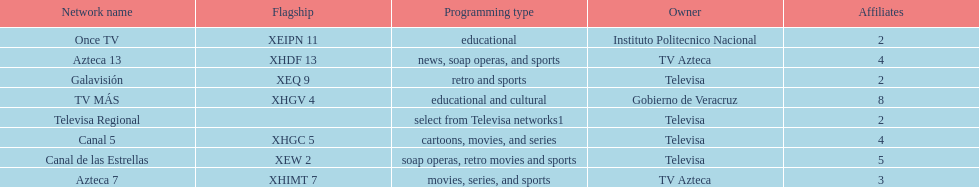Who has the most number of affiliates? TV MÁS. 